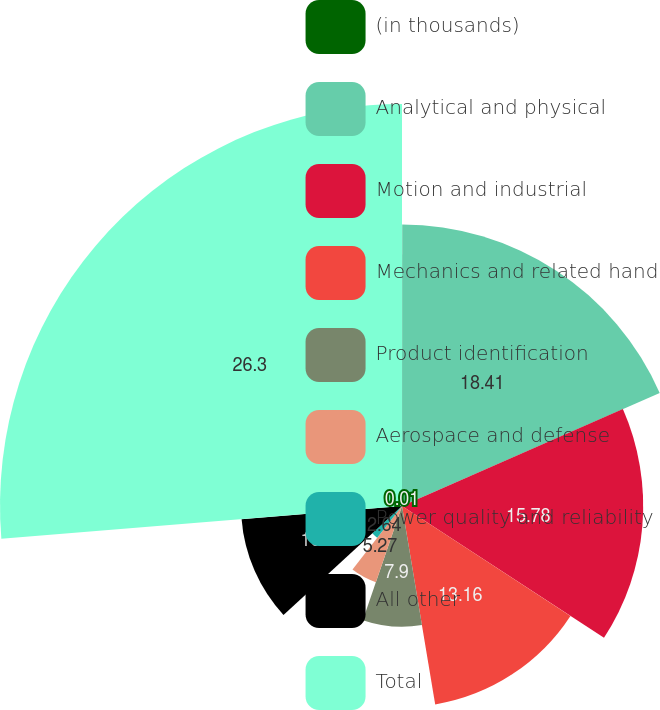Convert chart to OTSL. <chart><loc_0><loc_0><loc_500><loc_500><pie_chart><fcel>(in thousands)<fcel>Analytical and physical<fcel>Motion and industrial<fcel>Mechanics and related hand<fcel>Product identification<fcel>Aerospace and defense<fcel>Power quality and reliability<fcel>All other<fcel>Total<nl><fcel>0.01%<fcel>18.41%<fcel>15.78%<fcel>13.16%<fcel>7.9%<fcel>5.27%<fcel>2.64%<fcel>10.53%<fcel>26.3%<nl></chart> 